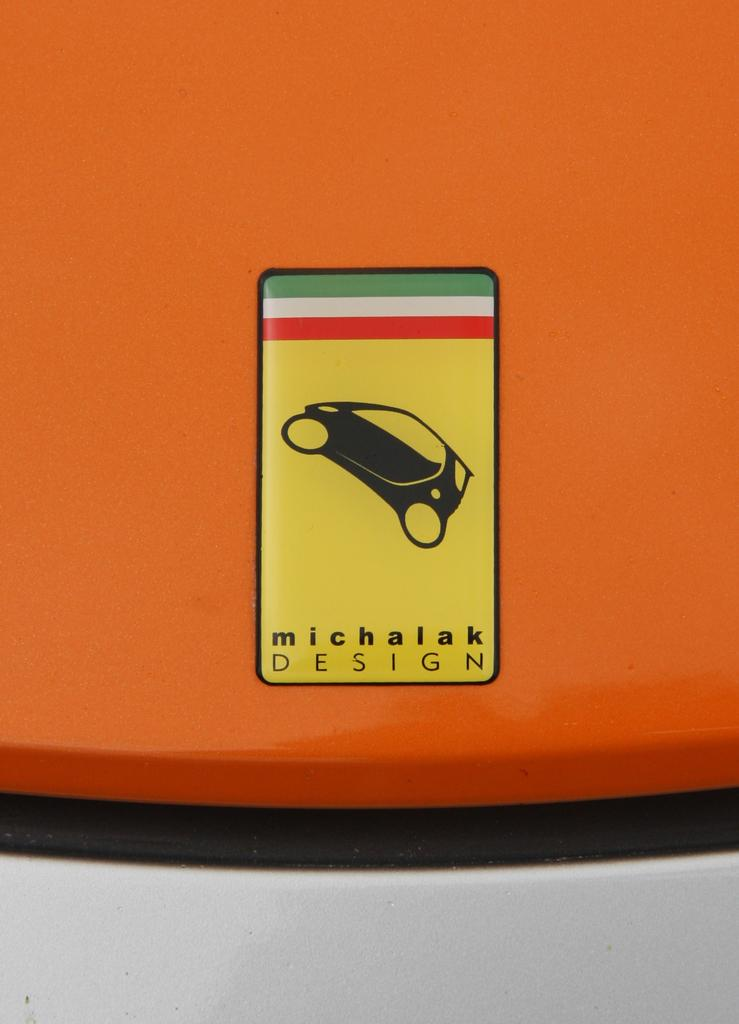What is the main symbol in the image? There is a car symbol in the image. What else can be seen in the image besides the car symbol? There is text in the image. What color is the background of the image? The background of the image is orange. What type of lumber is being used to construct the car symbol in the image? There is no lumber present in the image, as it features a car symbol and text on an orange background. 